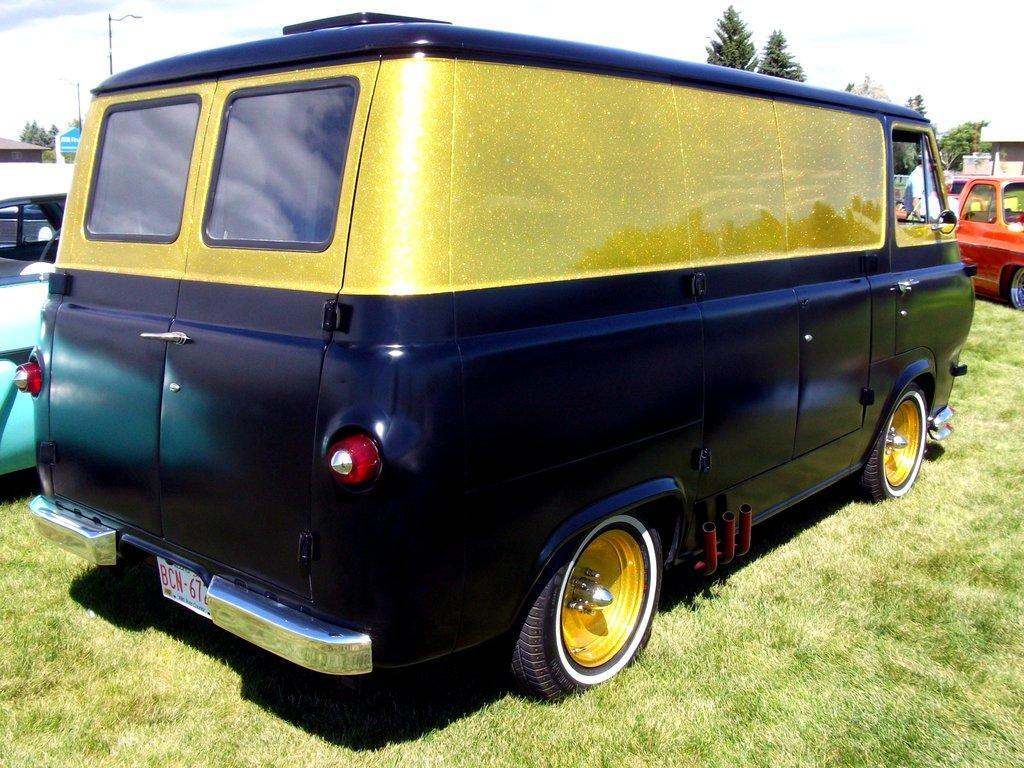In one or two sentences, can you explain what this image depicts? In this image in the center there are some vehicles, and some people at the bottom there is grass. And in the background there are some trees, houses, poles, street lights, boards. And at the top there is sky. 